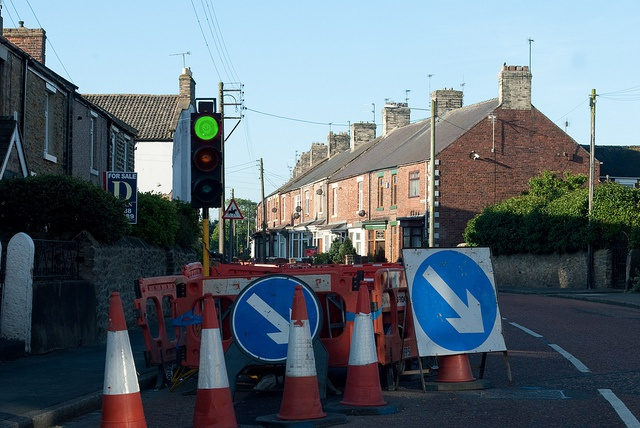Describe the objects in this image and their specific colors. I can see a traffic light in gray, black, green, and lime tones in this image. 